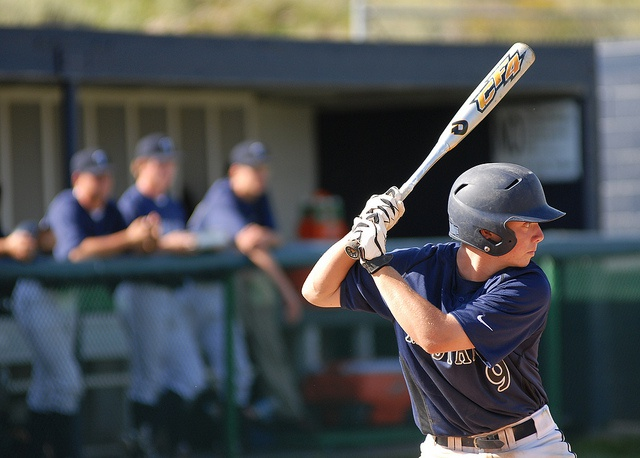Describe the objects in this image and their specific colors. I can see people in tan, black, white, navy, and gray tones, people in tan, gray, black, and blue tones, people in tan, gray, black, and blue tones, people in tan, black, gray, and blue tones, and baseball bat in tan, white, darkgray, and black tones in this image. 